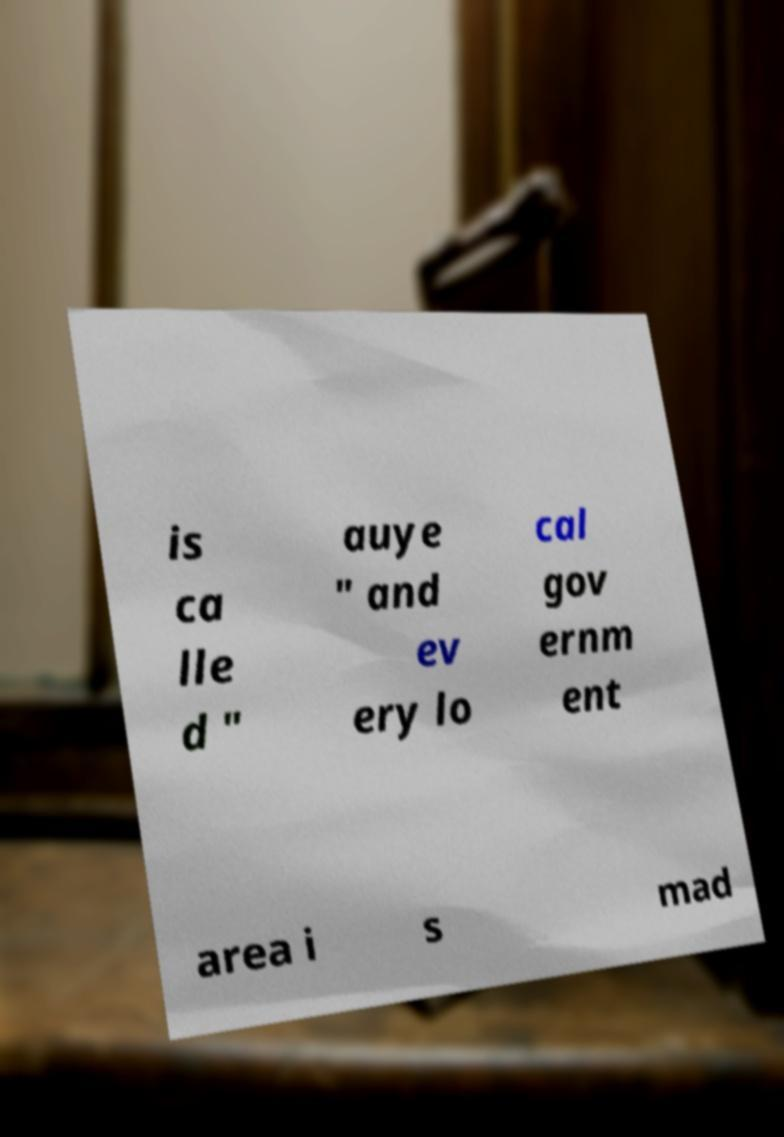For documentation purposes, I need the text within this image transcribed. Could you provide that? is ca lle d " auye " and ev ery lo cal gov ernm ent area i s mad 